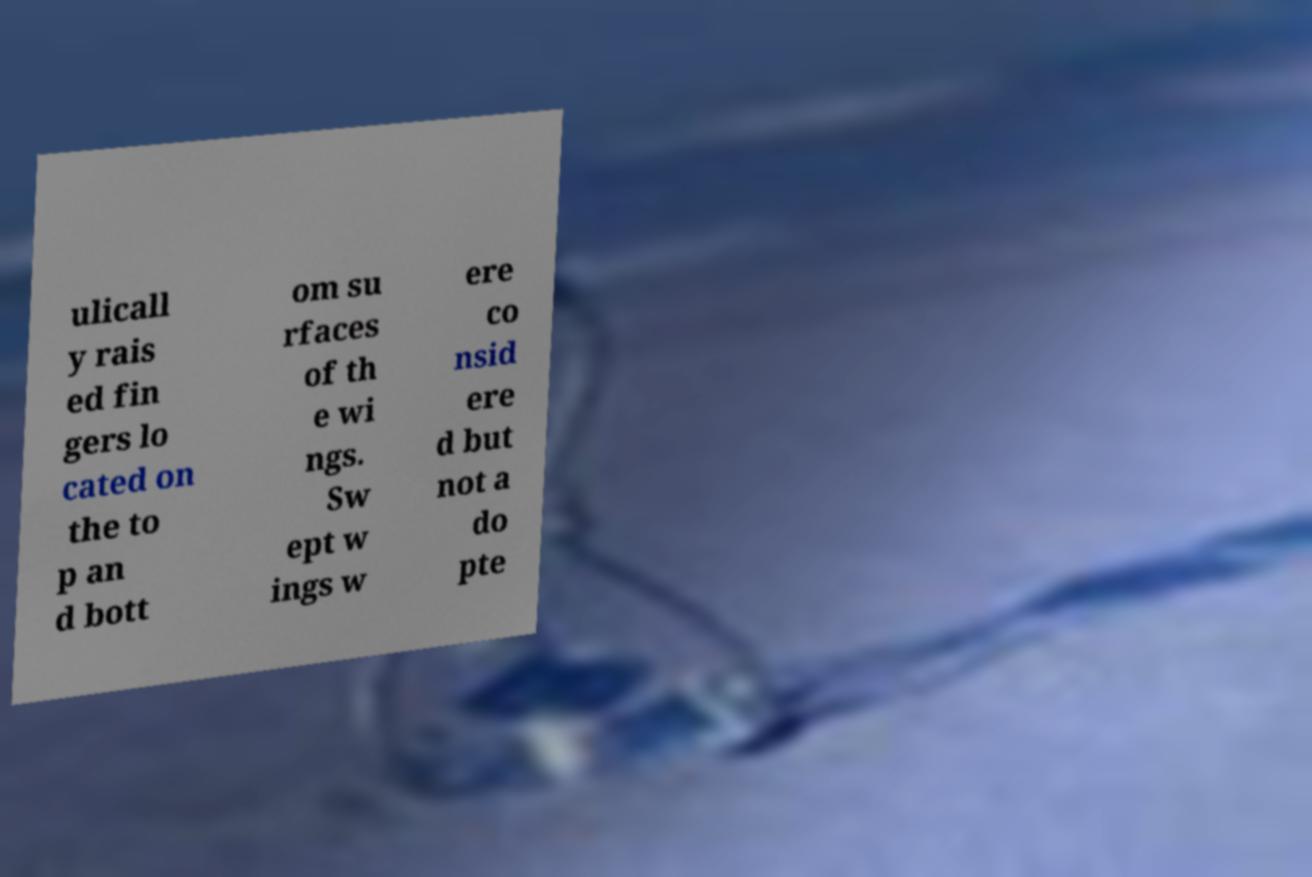I need the written content from this picture converted into text. Can you do that? ulicall y rais ed fin gers lo cated on the to p an d bott om su rfaces of th e wi ngs. Sw ept w ings w ere co nsid ere d but not a do pte 